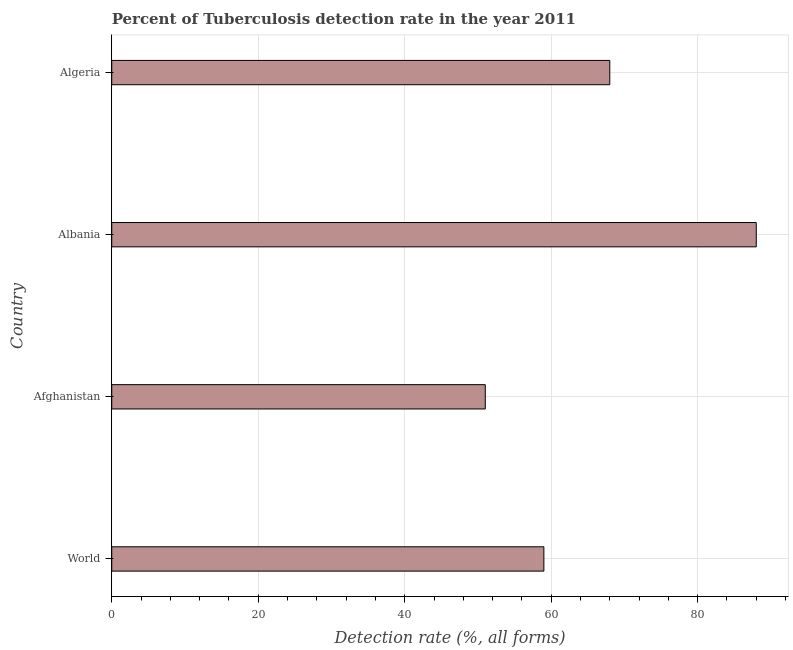Does the graph contain any zero values?
Give a very brief answer. No. What is the title of the graph?
Your answer should be compact. Percent of Tuberculosis detection rate in the year 2011. What is the label or title of the X-axis?
Make the answer very short. Detection rate (%, all forms). What is the label or title of the Y-axis?
Offer a very short reply. Country. Across all countries, what is the maximum detection rate of tuberculosis?
Ensure brevity in your answer.  88. In which country was the detection rate of tuberculosis maximum?
Provide a short and direct response. Albania. In which country was the detection rate of tuberculosis minimum?
Offer a very short reply. Afghanistan. What is the sum of the detection rate of tuberculosis?
Provide a succinct answer. 266. What is the average detection rate of tuberculosis per country?
Offer a terse response. 66. What is the median detection rate of tuberculosis?
Give a very brief answer. 63.5. In how many countries, is the detection rate of tuberculosis greater than 44 %?
Your response must be concise. 4. What is the ratio of the detection rate of tuberculosis in Algeria to that in World?
Your answer should be compact. 1.15. Is the detection rate of tuberculosis in Afghanistan less than that in World?
Your response must be concise. Yes. What is the difference between the highest and the second highest detection rate of tuberculosis?
Provide a short and direct response. 20. What is the difference between the highest and the lowest detection rate of tuberculosis?
Offer a terse response. 37. Are all the bars in the graph horizontal?
Provide a short and direct response. Yes. Are the values on the major ticks of X-axis written in scientific E-notation?
Your answer should be very brief. No. What is the Detection rate (%, all forms) of World?
Provide a succinct answer. 59. What is the Detection rate (%, all forms) of Albania?
Your answer should be very brief. 88. What is the Detection rate (%, all forms) in Algeria?
Your answer should be compact. 68. What is the difference between the Detection rate (%, all forms) in World and Algeria?
Make the answer very short. -9. What is the difference between the Detection rate (%, all forms) in Afghanistan and Albania?
Provide a short and direct response. -37. What is the difference between the Detection rate (%, all forms) in Afghanistan and Algeria?
Ensure brevity in your answer.  -17. What is the difference between the Detection rate (%, all forms) in Albania and Algeria?
Provide a succinct answer. 20. What is the ratio of the Detection rate (%, all forms) in World to that in Afghanistan?
Your answer should be compact. 1.16. What is the ratio of the Detection rate (%, all forms) in World to that in Albania?
Offer a very short reply. 0.67. What is the ratio of the Detection rate (%, all forms) in World to that in Algeria?
Make the answer very short. 0.87. What is the ratio of the Detection rate (%, all forms) in Afghanistan to that in Albania?
Ensure brevity in your answer.  0.58. What is the ratio of the Detection rate (%, all forms) in Albania to that in Algeria?
Give a very brief answer. 1.29. 